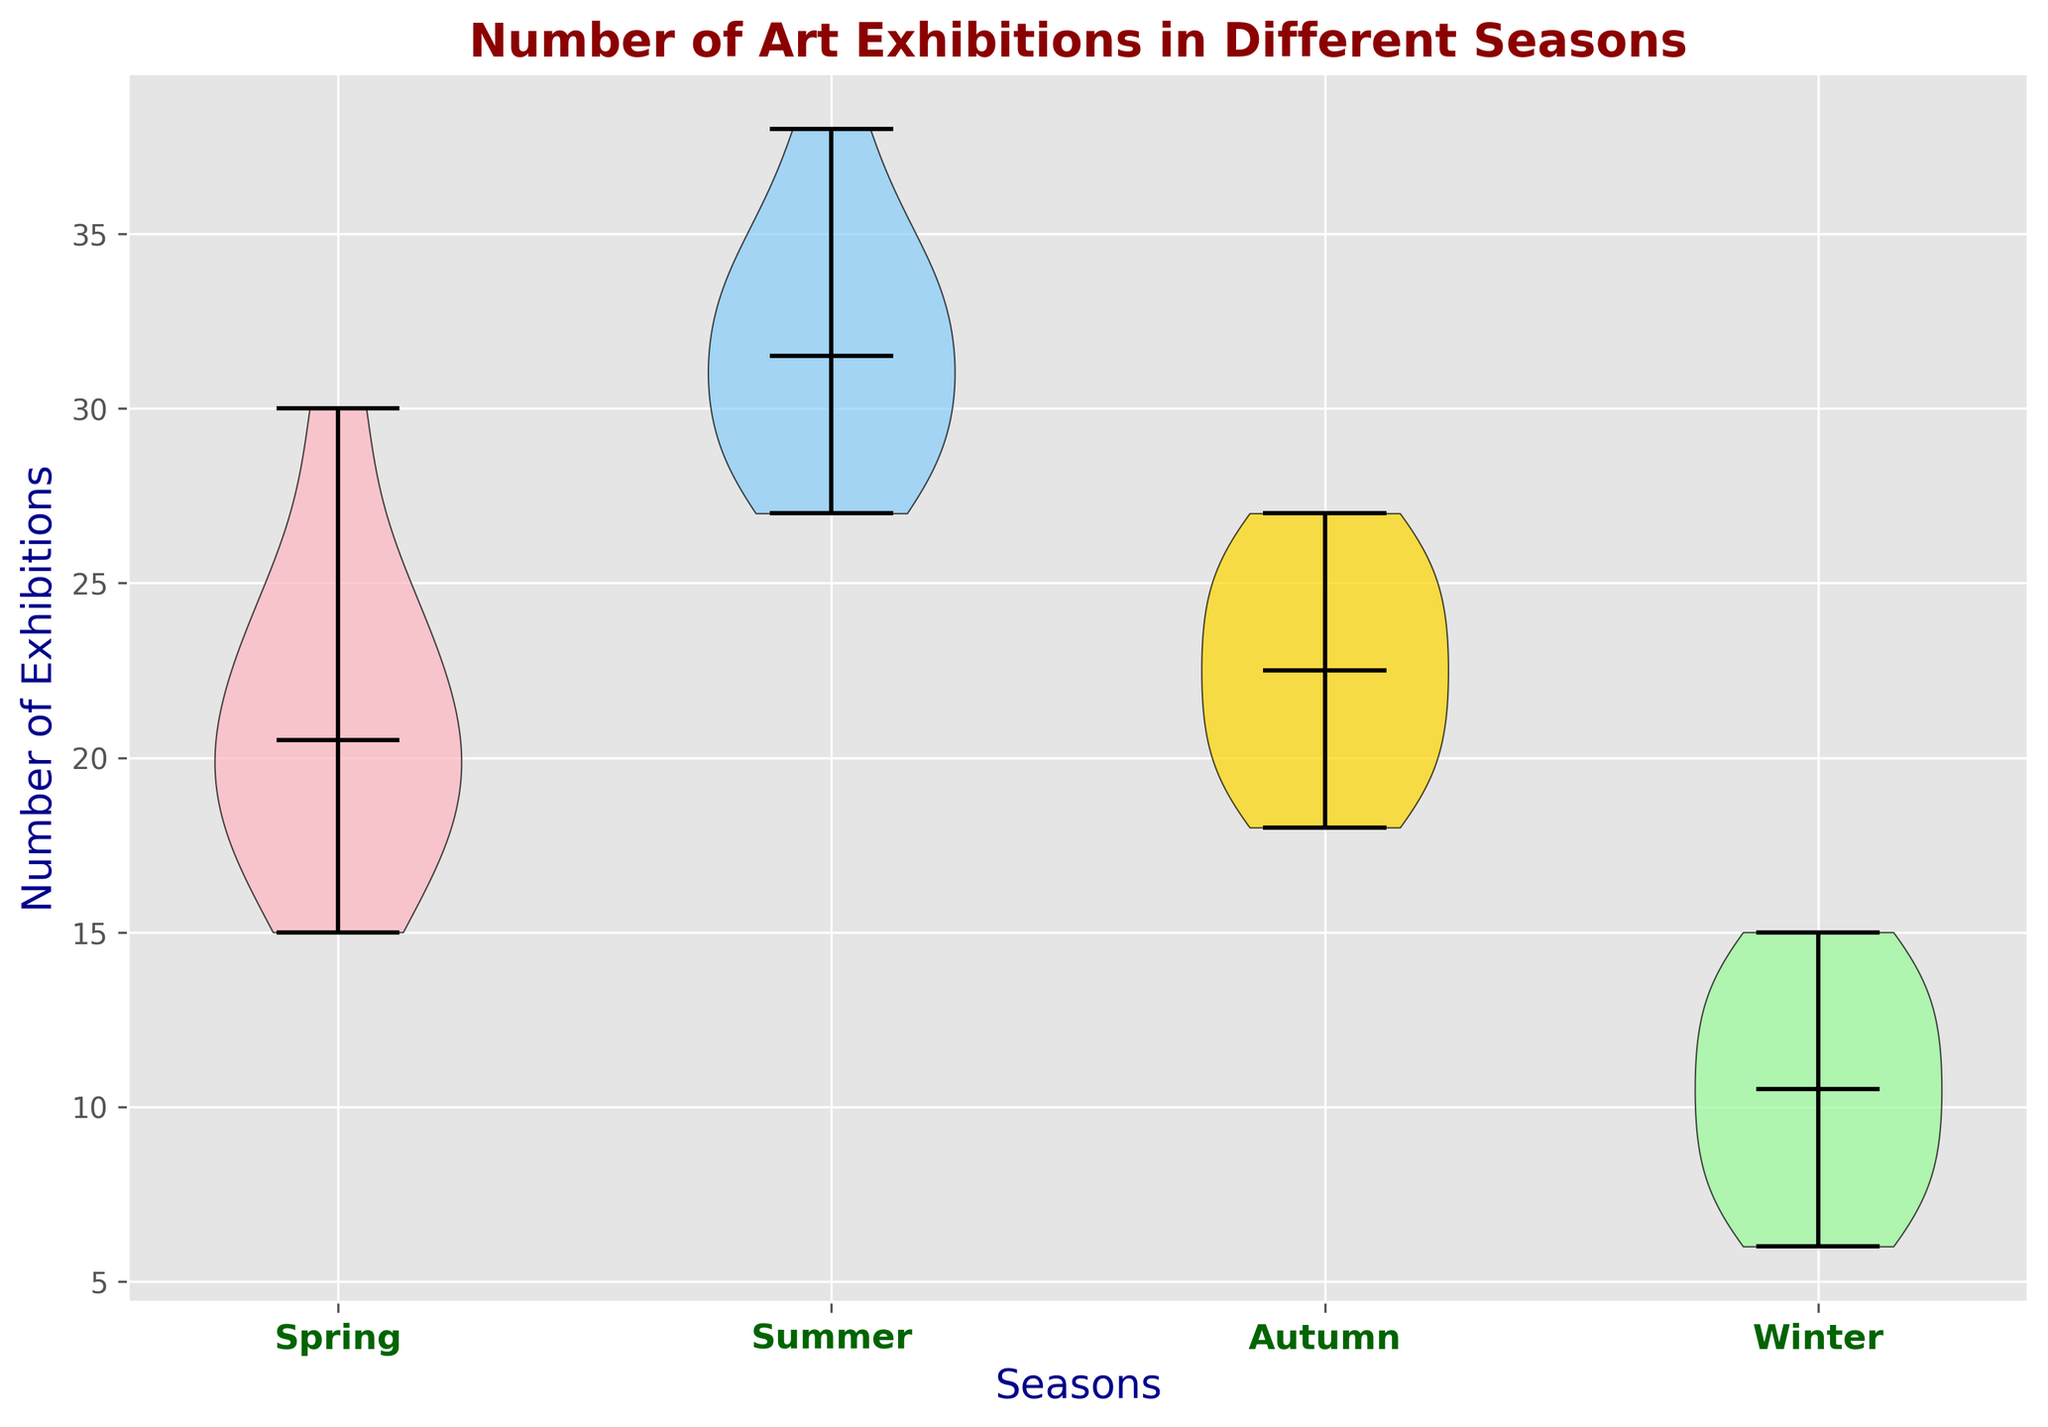Which season has the highest median number of art exhibitions? To identify the season with the highest median number of art exhibitions, look at the central line inside each violin plot, which represents the median. The season with the highest position of this line has the highest median.
Answer: Summer Which season has the most spread in the number of art exhibitions? To find the season with the most spread, observe the width and height of each violin plot. The wider and taller the plot, the more spread there is in the data.
Answer: Winter How does the median number of exhibitions in Spring compare to that of Winter? Look at the median lines of both Spring and Winter violin plots. The median line is generally lower in the Winter plot compared to the Spring plot, indicating fewer exhibitions in Winter.
Answer: Greater in Spring What is the range of the number of art exhibitions in Summer? Identify the minimum and maximum values of the Summer violin plot. The range is the difference between these two values. Summer ranges approximately from 27 to 38.
Answer: 11 Which season has the least variability in the number of art exhibitions? The season with the least variability will have the narrowest and shortest violin plot. Compare the plots visually, and Autumn has the least spread.
Answer: Autumn Order the seasons based on the median number of art exhibitions from highest to lowest. Look at the median lines in each violin plot and order the seasons accordingly. Summer has the highest median, followed by Spring, Autumn, and Winter.
Answer: Summer, Spring, Autumn, Winter Which color represents the number of art exhibitions in Spring? Identify the color assigned to the Spring violin plot in the figure. Spring is represented by a pinkish color.
Answer: Pink Compare the maximum number of exhibitions across all seasons. Which season has the highest maximum? Look at the top ends of each violin plot to identify the maximum number of exhibitions. The Summer plot extends the highest, indicating the highest maximum.
Answer: Summer What is the average range of the number of art exhibitions for Spring and Autumn? First, find the range of each by identifying the minimum and maximum values in the violin plots for Spring and Autumn. Spring ranges from 15 to 30 (range 15), and Autumn ranges from 18 to 27 (range 9). The average range is (15 + 9) / 2 = 12.
Answer: 12 